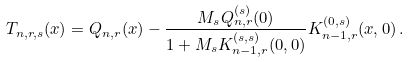Convert formula to latex. <formula><loc_0><loc_0><loc_500><loc_500>T _ { n , r , s } ( x ) = Q _ { n , r } ( x ) - \frac { M _ { s } Q _ { n , r } ^ { ( s ) } ( 0 ) } { 1 + M _ { s } K _ { n - 1 , r } ^ { ( s , s ) } ( 0 , 0 ) } K _ { n - 1 , r } ^ { ( 0 , s ) } ( x , 0 ) \, .</formula> 